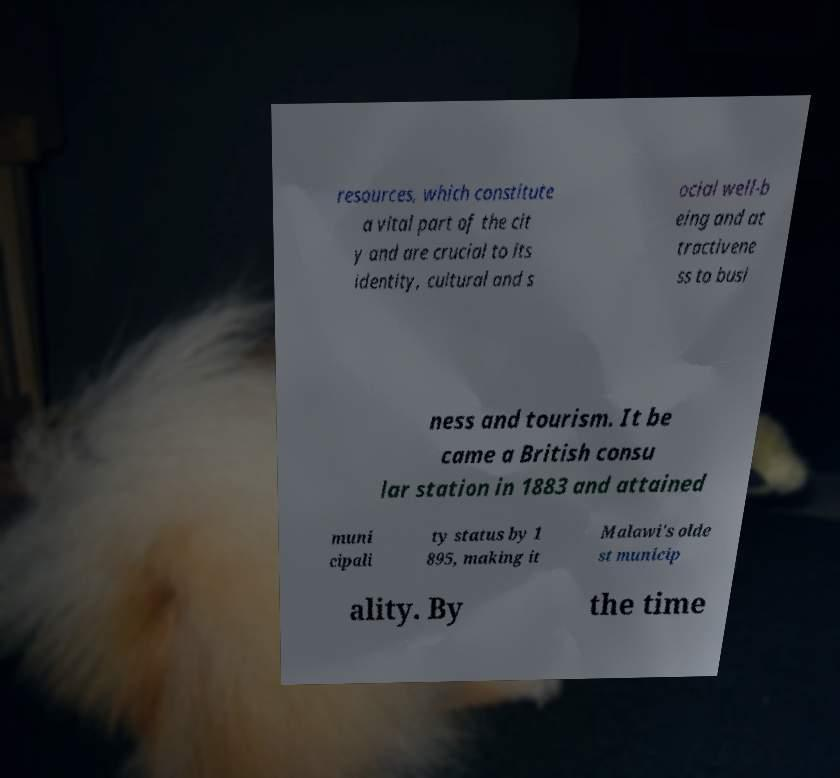Could you assist in decoding the text presented in this image and type it out clearly? resources, which constitute a vital part of the cit y and are crucial to its identity, cultural and s ocial well-b eing and at tractivene ss to busi ness and tourism. It be came a British consu lar station in 1883 and attained muni cipali ty status by 1 895, making it Malawi's olde st municip ality. By the time 